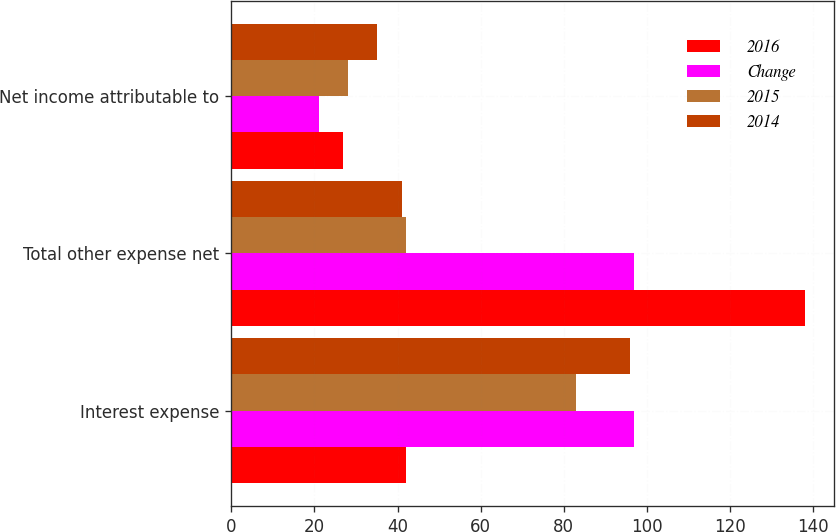Convert chart to OTSL. <chart><loc_0><loc_0><loc_500><loc_500><stacked_bar_chart><ecel><fcel>Interest expense<fcel>Total other expense net<fcel>Net income attributable to<nl><fcel>2016<fcel>42<fcel>138<fcel>27<nl><fcel>Change<fcel>97<fcel>97<fcel>21<nl><fcel>2015<fcel>83<fcel>42<fcel>28<nl><fcel>2014<fcel>96<fcel>41<fcel>35<nl></chart> 